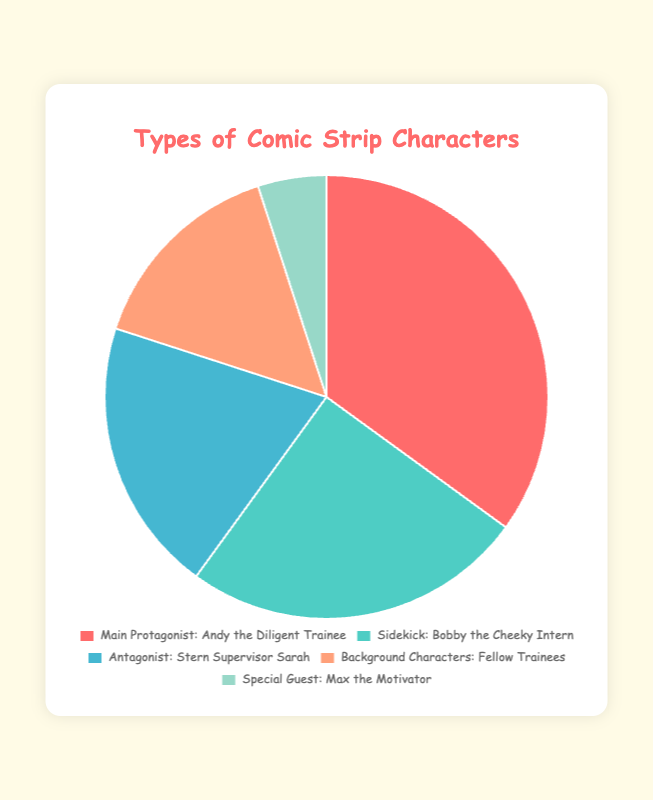Which type of character has the largest percentage? The type of character with the largest percentage can be identified by looking at the largest segment of the pie chart. This segment is labeled "Main Protagonist: Andy the Diligent Trainee" with a 35% share.
Answer: Main Protagonist Which character is represented by the smallest segment in the pie chart? The smallest segment in the pie chart represents the character with the lowest percentage. The "Special Guest Characters: Max the Motivator" segment is the smallest with 5%.
Answer: Max the Motivator How much larger is the percentage of Main Protagonist compared to Special Guest Characters? Find the percentage of the Main Protagonist and Special Guest Characters, which are 35% and 5% respectively, then subtract the smaller from the larger: 35% - 5% = 30%.
Answer: 30% What is the sum of the percentages of the Sidekick and Background Characters? Add the percentage of the Sidekick (25%) to the percentage of the Background Characters (15%): 25% + 15% = 40%.
Answer: 40% Which type of character constitutes exactly one-fifth of the total characters? One-fifth of 100% is 20%. The section for "Antagonist: Stern Supervisor Sarah" is 20%, fitting this criterion perfectly.
Answer: Antagonist How do the combined percentages of Main Protagonist and Sidekick compare to the percentage of all other characters? Add the percentage of the Main Protagonist (35%) and the Sidekick (25%) to get 60%. Then, add the percentages of the other characters: Antagonist (20%) + Background Characters (15%) + Special Guest Characters (5%) = 40%. Therefore, Main Protagonist and Sidekick combined (60%) is larger than all other characters combined (40%).
Answer: Larger What is the difference in percentage between the Sidekick and the Background Characters? Subtract the percentage of Background Characters (15%) from the percentage of the Sidekick (25%): 25% - 15% = 10%.
Answer: 10% What color represents the Antagonist in the pie chart? By analyzing the colors used for each segment, the Antagonist "Stern Supervisor Sarah" is represented by the third color counting clockwise, which is light blue.
Answer: Light blue What is the average percentage of all character types excluding the Main Protagonist? Add the percentages of all character types excluding the Main Protagonist: Sidekick (25%), Antagonist (20%), Background Characters (15%), Special Guest Characters (5%) totals 65%. Dividing by 4 gives the average: 65% / 4 = 16.25%.
Answer: 16.25% How does the percentage of the Antagonist compare to the total percentage of Background Characters and Special Guest Characters combined? Add the percentages of Background Characters (15%) and Special Guest Characters (5%), getting 20%. The percentage for the Antagonist is also 20%, meaning they are equal.
Answer: Equal 